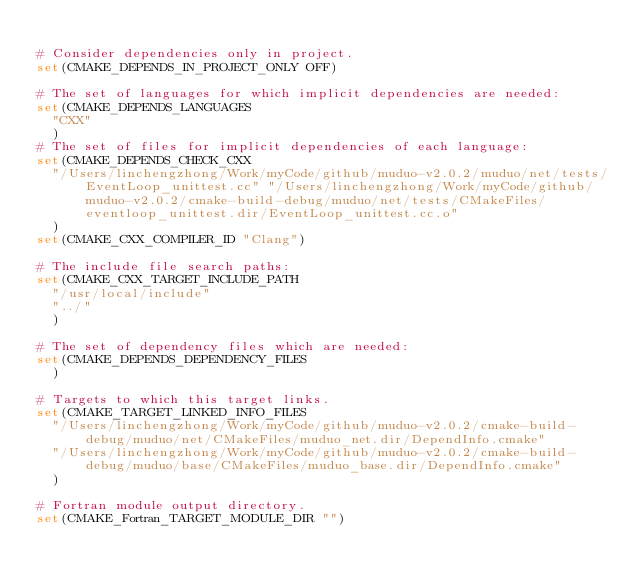<code> <loc_0><loc_0><loc_500><loc_500><_CMake_>
# Consider dependencies only in project.
set(CMAKE_DEPENDS_IN_PROJECT_ONLY OFF)

# The set of languages for which implicit dependencies are needed:
set(CMAKE_DEPENDS_LANGUAGES
  "CXX"
  )
# The set of files for implicit dependencies of each language:
set(CMAKE_DEPENDS_CHECK_CXX
  "/Users/linchengzhong/Work/myCode/github/muduo-v2.0.2/muduo/net/tests/EventLoop_unittest.cc" "/Users/linchengzhong/Work/myCode/github/muduo-v2.0.2/cmake-build-debug/muduo/net/tests/CMakeFiles/eventloop_unittest.dir/EventLoop_unittest.cc.o"
  )
set(CMAKE_CXX_COMPILER_ID "Clang")

# The include file search paths:
set(CMAKE_CXX_TARGET_INCLUDE_PATH
  "/usr/local/include"
  "../"
  )

# The set of dependency files which are needed:
set(CMAKE_DEPENDS_DEPENDENCY_FILES
  )

# Targets to which this target links.
set(CMAKE_TARGET_LINKED_INFO_FILES
  "/Users/linchengzhong/Work/myCode/github/muduo-v2.0.2/cmake-build-debug/muduo/net/CMakeFiles/muduo_net.dir/DependInfo.cmake"
  "/Users/linchengzhong/Work/myCode/github/muduo-v2.0.2/cmake-build-debug/muduo/base/CMakeFiles/muduo_base.dir/DependInfo.cmake"
  )

# Fortran module output directory.
set(CMAKE_Fortran_TARGET_MODULE_DIR "")
</code> 